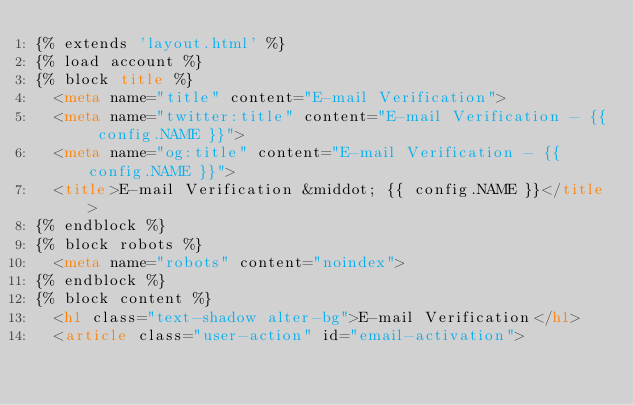Convert code to text. <code><loc_0><loc_0><loc_500><loc_500><_HTML_>{% extends 'layout.html' %}
{% load account %}
{% block title %}
  <meta name="title" content="E-mail Verification">
  <meta name="twitter:title" content="E-mail Verification - {{ config.NAME }}">
  <meta name="og:title" content="E-mail Verification - {{ config.NAME }}">
  <title>E-mail Verification &middot; {{ config.NAME }}</title>
{% endblock %}
{% block robots %}
  <meta name="robots" content="noindex">
{% endblock %}
{% block content %}
  <h1 class="text-shadow alter-bg">E-mail Verification</h1>
  <article class="user-action" id="email-activation"></code> 